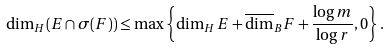<formula> <loc_0><loc_0><loc_500><loc_500>\dim _ { H } ( E \cap \sigma ( F ) ) \leq \max \left \{ \dim _ { H } E + \overline { \dim } _ { B } F + \frac { \log m } { \log r } , 0 \right \} .</formula> 